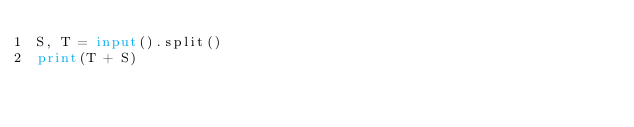Convert code to text. <code><loc_0><loc_0><loc_500><loc_500><_Python_>S, T = input().split()
print(T + S)</code> 